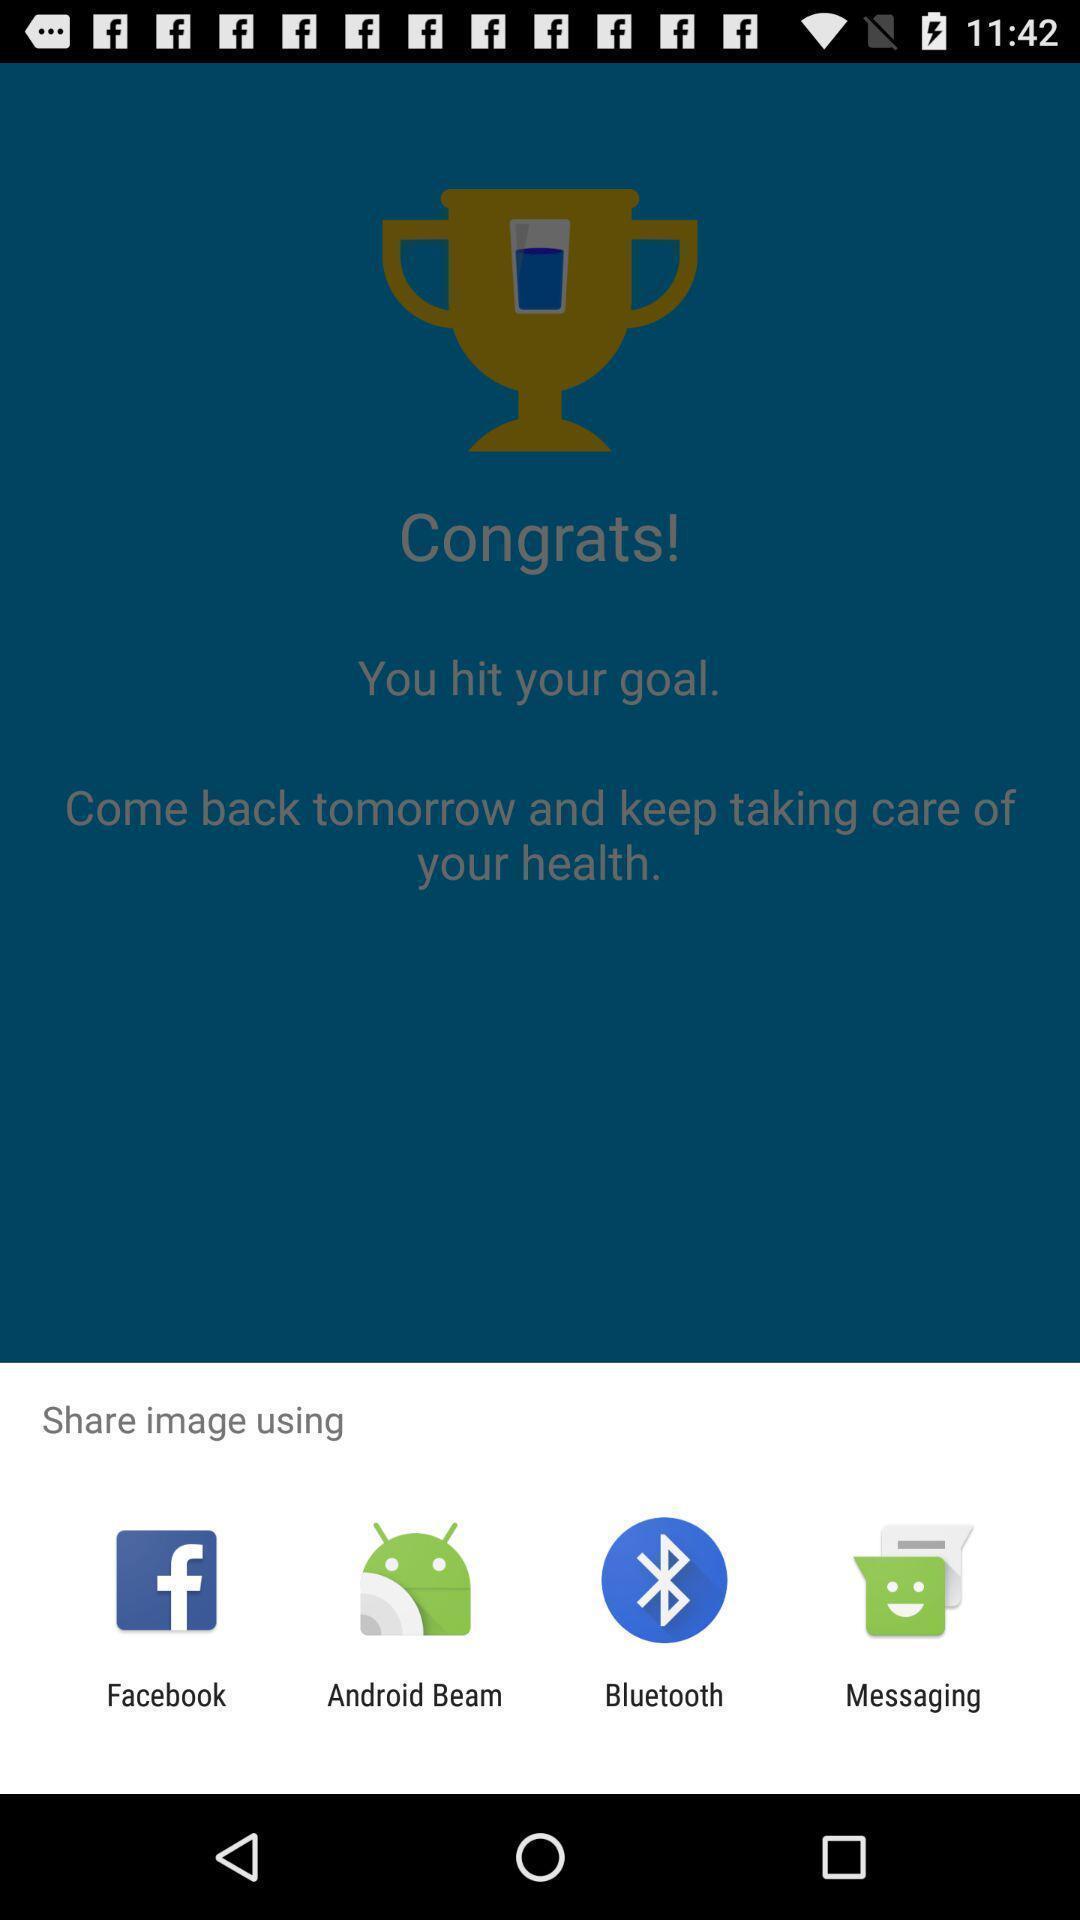Provide a description of this screenshot. Screen showing various applications to share. 